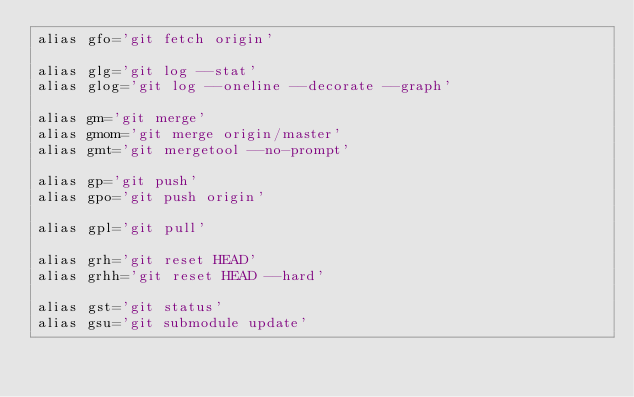<code> <loc_0><loc_0><loc_500><loc_500><_Bash_>alias gfo='git fetch origin'

alias glg='git log --stat'
alias glog='git log --oneline --decorate --graph'

alias gm='git merge'
alias gmom='git merge origin/master'
alias gmt='git mergetool --no-prompt'

alias gp='git push'
alias gpo='git push origin'

alias gpl='git pull'

alias grh='git reset HEAD'
alias grhh='git reset HEAD --hard'

alias gst='git status'
alias gsu='git submodule update'</code> 